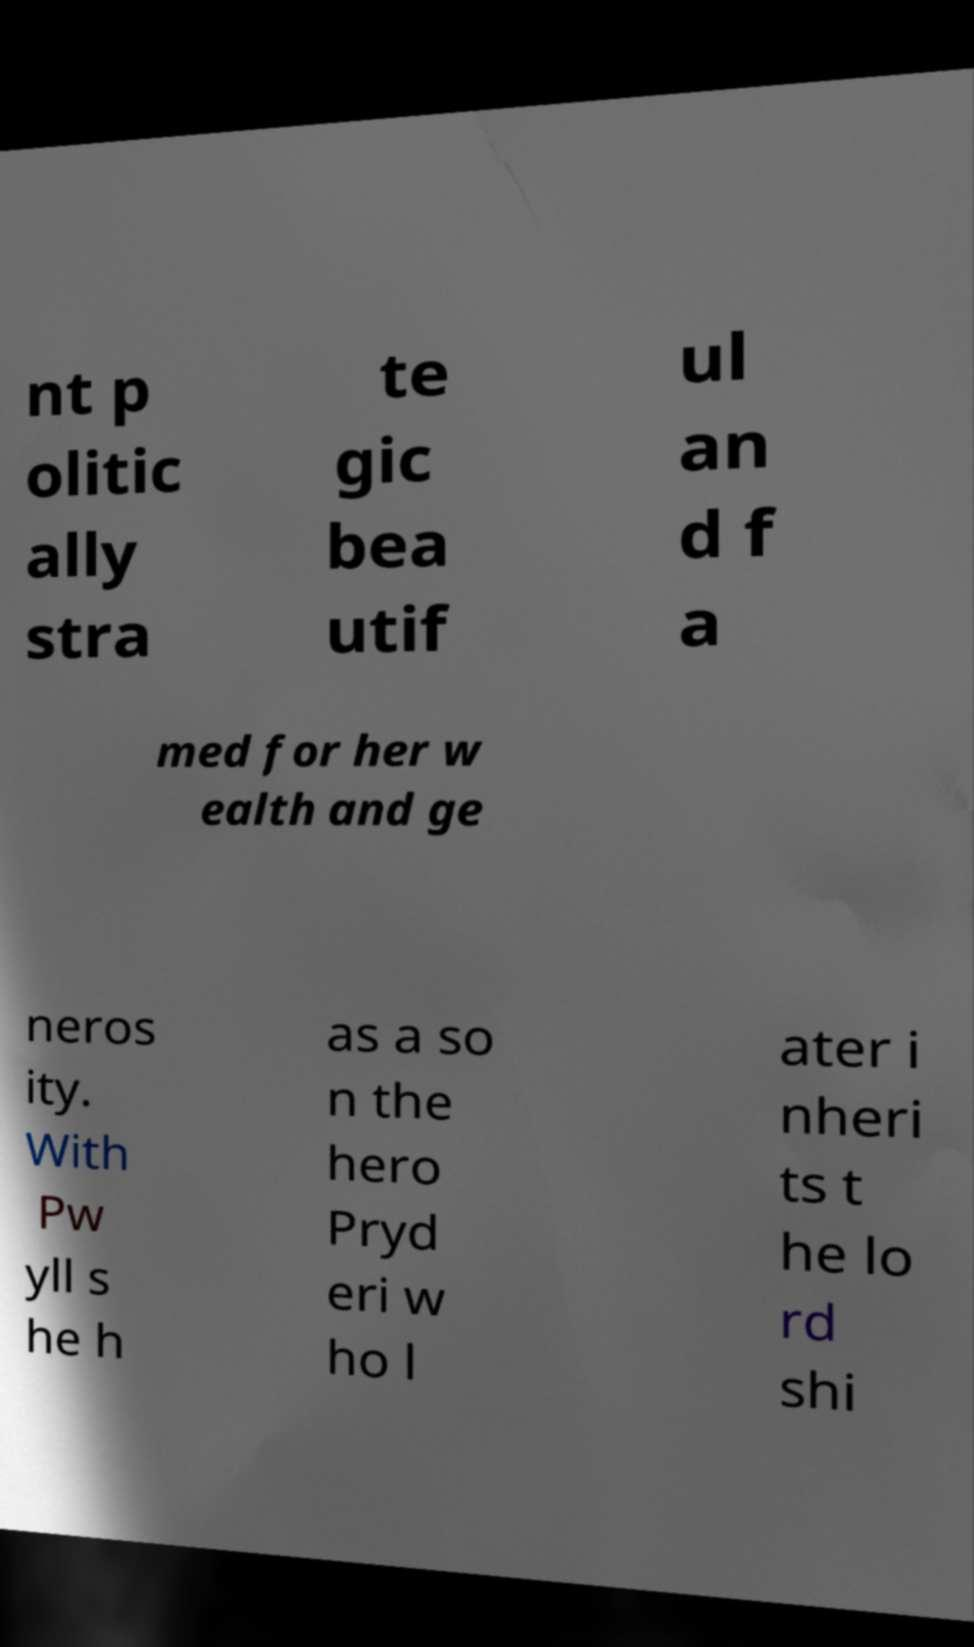Could you assist in decoding the text presented in this image and type it out clearly? nt p olitic ally stra te gic bea utif ul an d f a med for her w ealth and ge neros ity. With Pw yll s he h as a so n the hero Pryd eri w ho l ater i nheri ts t he lo rd shi 